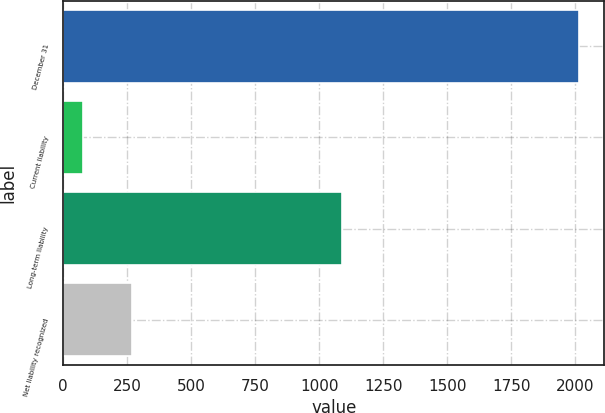<chart> <loc_0><loc_0><loc_500><loc_500><bar_chart><fcel>December 31<fcel>Current liability<fcel>Long-term liability<fcel>Net liability recognized<nl><fcel>2013<fcel>76<fcel>1090<fcel>269.7<nl></chart> 